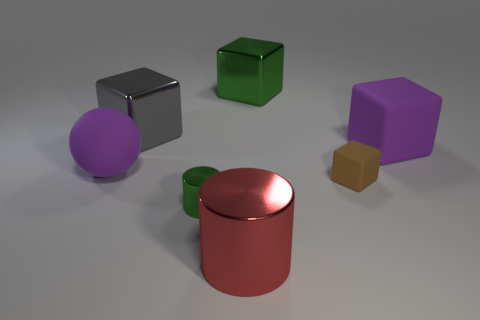Subtract all large purple cubes. How many cubes are left? 3 Subtract all balls. How many objects are left? 6 Subtract 1 balls. How many balls are left? 0 Add 4 spheres. How many spheres are left? 5 Add 2 red rubber cylinders. How many red rubber cylinders exist? 2 Add 2 small rubber cubes. How many objects exist? 9 Subtract all green cylinders. How many cylinders are left? 1 Subtract 0 yellow cylinders. How many objects are left? 7 Subtract all brown cylinders. Subtract all purple blocks. How many cylinders are left? 2 Subtract all brown spheres. How many purple cylinders are left? 0 